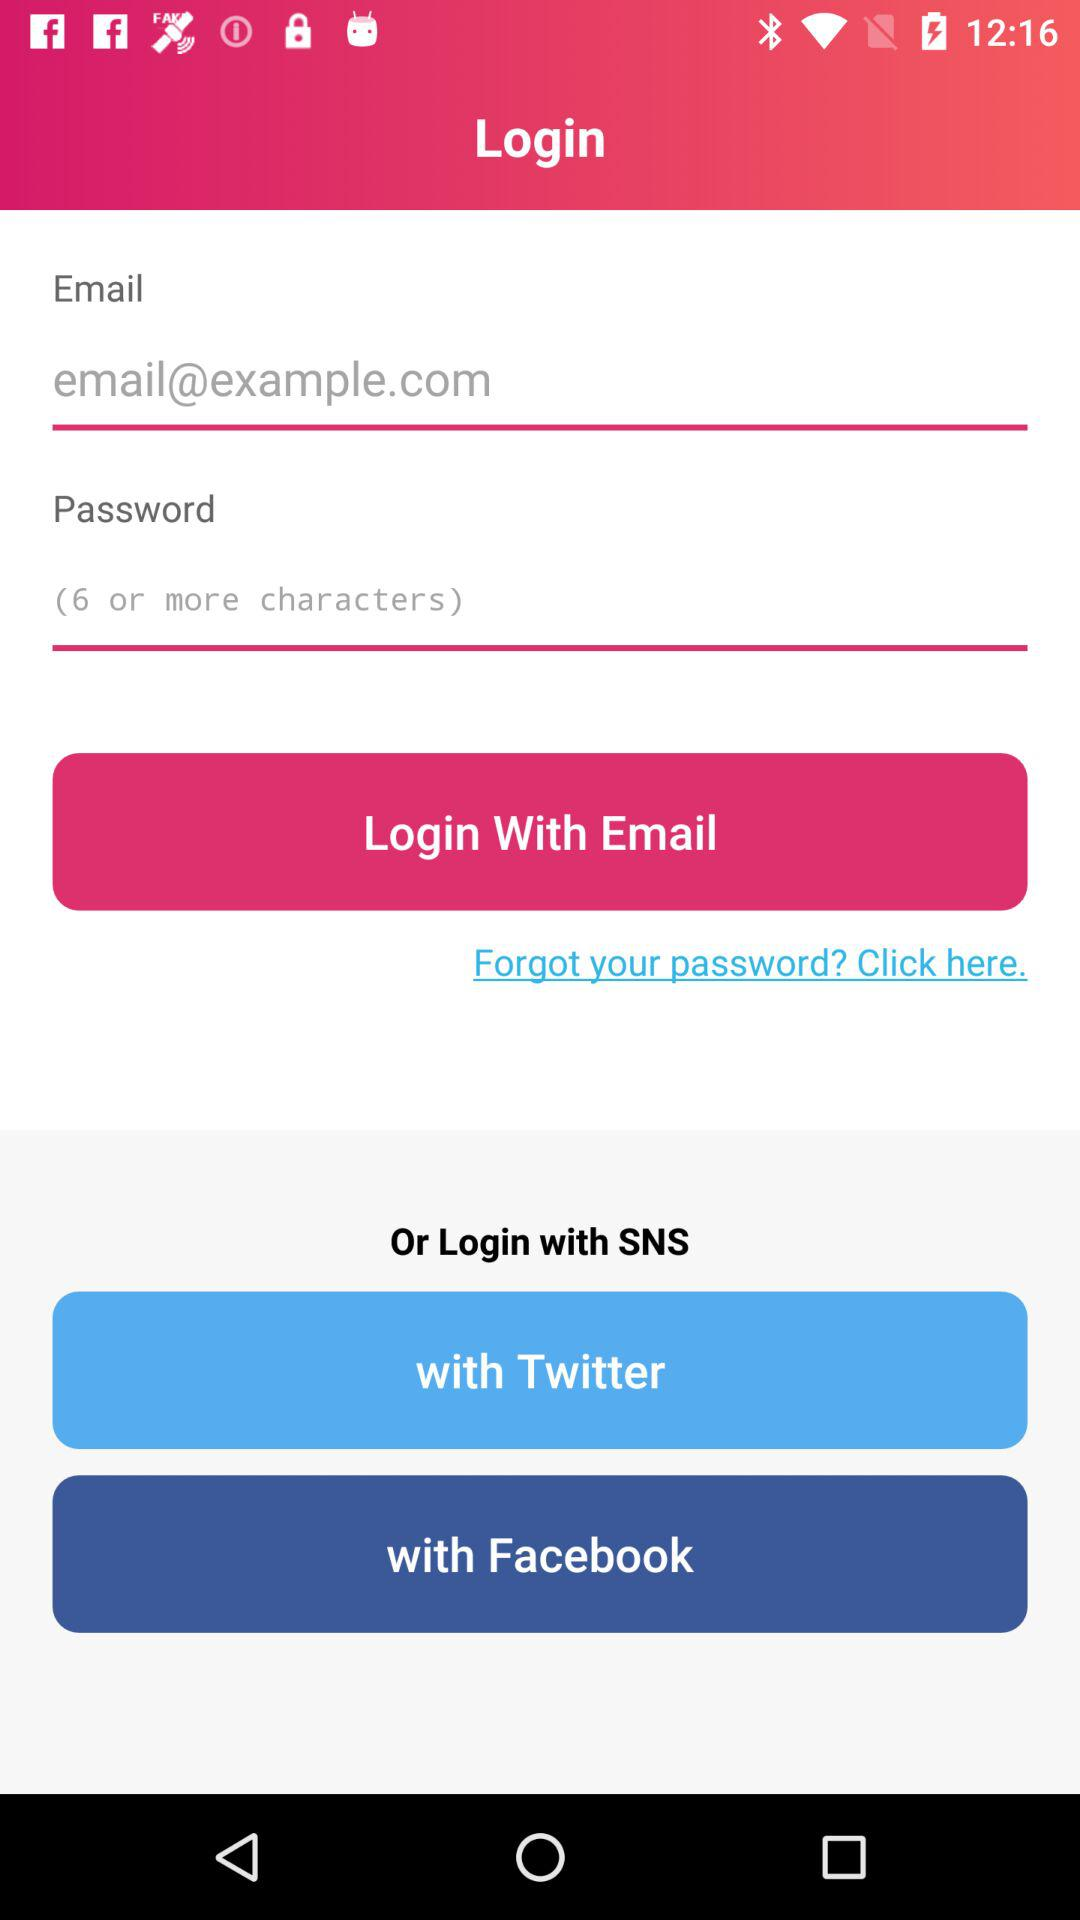How many characters are required in the password? There are 6 or more characters required in the password. 